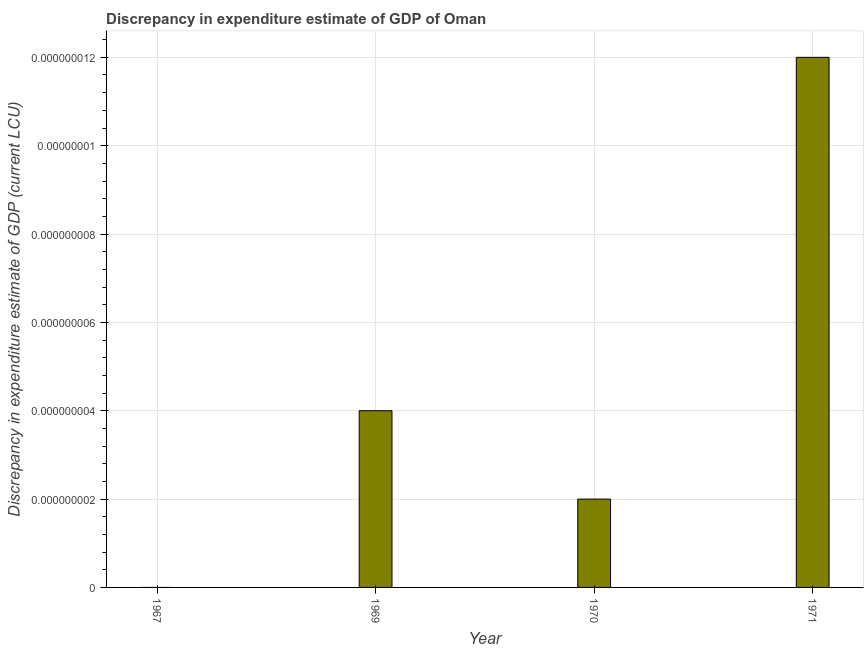Does the graph contain grids?
Provide a short and direct response. Yes. What is the title of the graph?
Provide a succinct answer. Discrepancy in expenditure estimate of GDP of Oman. What is the label or title of the Y-axis?
Your answer should be very brief. Discrepancy in expenditure estimate of GDP (current LCU). What is the discrepancy in expenditure estimate of gdp in 1970?
Your answer should be very brief. 2e-9. Across all years, what is the maximum discrepancy in expenditure estimate of gdp?
Make the answer very short. 1.2e-8. Across all years, what is the minimum discrepancy in expenditure estimate of gdp?
Make the answer very short. 0. In which year was the discrepancy in expenditure estimate of gdp maximum?
Your answer should be very brief. 1971. What is the sum of the discrepancy in expenditure estimate of gdp?
Offer a terse response. 1.8000000000000002e-8. What is the average discrepancy in expenditure estimate of gdp per year?
Your response must be concise. 0. What is the median discrepancy in expenditure estimate of gdp?
Your response must be concise. 3.0000000000000004e-9. Is the discrepancy in expenditure estimate of gdp in 1970 less than that in 1971?
Your answer should be compact. Yes. Is the difference between the discrepancy in expenditure estimate of gdp in 1969 and 1971 greater than the difference between any two years?
Give a very brief answer. No. What is the difference between the highest and the second highest discrepancy in expenditure estimate of gdp?
Provide a succinct answer. 0. Is the sum of the discrepancy in expenditure estimate of gdp in 1969 and 1971 greater than the maximum discrepancy in expenditure estimate of gdp across all years?
Offer a very short reply. Yes. What is the difference between the highest and the lowest discrepancy in expenditure estimate of gdp?
Provide a short and direct response. 0. Are all the bars in the graph horizontal?
Your answer should be very brief. No. How many years are there in the graph?
Your answer should be compact. 4. What is the difference between two consecutive major ticks on the Y-axis?
Give a very brief answer. 2e-9. What is the Discrepancy in expenditure estimate of GDP (current LCU) in 1967?
Provide a succinct answer. 0. What is the Discrepancy in expenditure estimate of GDP (current LCU) in 1969?
Your answer should be compact. 4e-9. What is the Discrepancy in expenditure estimate of GDP (current LCU) in 1970?
Your answer should be very brief. 2e-9. What is the Discrepancy in expenditure estimate of GDP (current LCU) in 1971?
Ensure brevity in your answer.  1.2e-8. What is the difference between the Discrepancy in expenditure estimate of GDP (current LCU) in 1969 and 1970?
Offer a very short reply. 0. What is the ratio of the Discrepancy in expenditure estimate of GDP (current LCU) in 1969 to that in 1970?
Your response must be concise. 2. What is the ratio of the Discrepancy in expenditure estimate of GDP (current LCU) in 1969 to that in 1971?
Keep it short and to the point. 0.33. What is the ratio of the Discrepancy in expenditure estimate of GDP (current LCU) in 1970 to that in 1971?
Give a very brief answer. 0.17. 